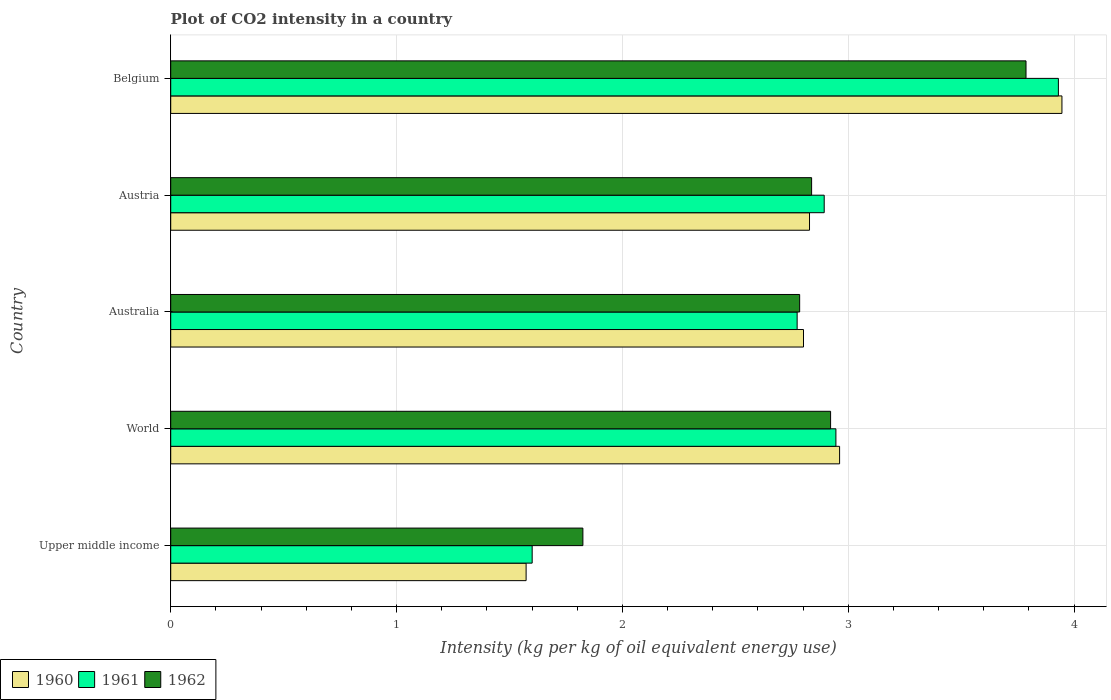Are the number of bars on each tick of the Y-axis equal?
Your answer should be compact. Yes. How many bars are there on the 2nd tick from the top?
Your answer should be very brief. 3. How many bars are there on the 5th tick from the bottom?
Your answer should be compact. 3. What is the label of the 1st group of bars from the top?
Provide a succinct answer. Belgium. In how many cases, is the number of bars for a given country not equal to the number of legend labels?
Provide a succinct answer. 0. What is the CO2 intensity in in 1962 in Upper middle income?
Make the answer very short. 1.82. Across all countries, what is the maximum CO2 intensity in in 1960?
Provide a succinct answer. 3.95. Across all countries, what is the minimum CO2 intensity in in 1962?
Your answer should be very brief. 1.82. In which country was the CO2 intensity in in 1961 maximum?
Give a very brief answer. Belgium. In which country was the CO2 intensity in in 1962 minimum?
Offer a very short reply. Upper middle income. What is the total CO2 intensity in in 1962 in the graph?
Ensure brevity in your answer.  14.16. What is the difference between the CO2 intensity in in 1960 in Upper middle income and that in World?
Your answer should be very brief. -1.39. What is the difference between the CO2 intensity in in 1961 in World and the CO2 intensity in in 1962 in Australia?
Your response must be concise. 0.16. What is the average CO2 intensity in in 1960 per country?
Your response must be concise. 2.82. What is the difference between the CO2 intensity in in 1962 and CO2 intensity in in 1961 in Belgium?
Give a very brief answer. -0.14. What is the ratio of the CO2 intensity in in 1961 in Australia to that in Upper middle income?
Your answer should be compact. 1.73. Is the CO2 intensity in in 1960 in Belgium less than that in World?
Your response must be concise. No. What is the difference between the highest and the second highest CO2 intensity in in 1961?
Your answer should be compact. 0.99. What is the difference between the highest and the lowest CO2 intensity in in 1961?
Offer a very short reply. 2.33. What does the 2nd bar from the top in World represents?
Your answer should be compact. 1961. Is it the case that in every country, the sum of the CO2 intensity in in 1962 and CO2 intensity in in 1961 is greater than the CO2 intensity in in 1960?
Your answer should be compact. Yes. Are all the bars in the graph horizontal?
Keep it short and to the point. Yes. How many countries are there in the graph?
Give a very brief answer. 5. What is the difference between two consecutive major ticks on the X-axis?
Make the answer very short. 1. Does the graph contain any zero values?
Your answer should be compact. No. What is the title of the graph?
Offer a terse response. Plot of CO2 intensity in a country. What is the label or title of the X-axis?
Your answer should be compact. Intensity (kg per kg of oil equivalent energy use). What is the Intensity (kg per kg of oil equivalent energy use) of 1960 in Upper middle income?
Your response must be concise. 1.57. What is the Intensity (kg per kg of oil equivalent energy use) in 1961 in Upper middle income?
Make the answer very short. 1.6. What is the Intensity (kg per kg of oil equivalent energy use) in 1962 in Upper middle income?
Give a very brief answer. 1.82. What is the Intensity (kg per kg of oil equivalent energy use) in 1960 in World?
Your response must be concise. 2.96. What is the Intensity (kg per kg of oil equivalent energy use) in 1961 in World?
Your answer should be compact. 2.95. What is the Intensity (kg per kg of oil equivalent energy use) of 1962 in World?
Make the answer very short. 2.92. What is the Intensity (kg per kg of oil equivalent energy use) in 1960 in Australia?
Provide a succinct answer. 2.8. What is the Intensity (kg per kg of oil equivalent energy use) of 1961 in Australia?
Provide a short and direct response. 2.77. What is the Intensity (kg per kg of oil equivalent energy use) of 1962 in Australia?
Your response must be concise. 2.78. What is the Intensity (kg per kg of oil equivalent energy use) in 1960 in Austria?
Offer a very short reply. 2.83. What is the Intensity (kg per kg of oil equivalent energy use) in 1961 in Austria?
Give a very brief answer. 2.89. What is the Intensity (kg per kg of oil equivalent energy use) of 1962 in Austria?
Ensure brevity in your answer.  2.84. What is the Intensity (kg per kg of oil equivalent energy use) of 1960 in Belgium?
Your response must be concise. 3.95. What is the Intensity (kg per kg of oil equivalent energy use) of 1961 in Belgium?
Keep it short and to the point. 3.93. What is the Intensity (kg per kg of oil equivalent energy use) in 1962 in Belgium?
Your response must be concise. 3.79. Across all countries, what is the maximum Intensity (kg per kg of oil equivalent energy use) of 1960?
Ensure brevity in your answer.  3.95. Across all countries, what is the maximum Intensity (kg per kg of oil equivalent energy use) of 1961?
Give a very brief answer. 3.93. Across all countries, what is the maximum Intensity (kg per kg of oil equivalent energy use) in 1962?
Make the answer very short. 3.79. Across all countries, what is the minimum Intensity (kg per kg of oil equivalent energy use) in 1960?
Your answer should be very brief. 1.57. Across all countries, what is the minimum Intensity (kg per kg of oil equivalent energy use) in 1961?
Provide a short and direct response. 1.6. Across all countries, what is the minimum Intensity (kg per kg of oil equivalent energy use) of 1962?
Provide a short and direct response. 1.82. What is the total Intensity (kg per kg of oil equivalent energy use) of 1960 in the graph?
Your response must be concise. 14.11. What is the total Intensity (kg per kg of oil equivalent energy use) in 1961 in the graph?
Provide a short and direct response. 14.14. What is the total Intensity (kg per kg of oil equivalent energy use) of 1962 in the graph?
Your answer should be compact. 14.16. What is the difference between the Intensity (kg per kg of oil equivalent energy use) of 1960 in Upper middle income and that in World?
Your answer should be very brief. -1.39. What is the difference between the Intensity (kg per kg of oil equivalent energy use) of 1961 in Upper middle income and that in World?
Your answer should be compact. -1.34. What is the difference between the Intensity (kg per kg of oil equivalent energy use) in 1962 in Upper middle income and that in World?
Make the answer very short. -1.1. What is the difference between the Intensity (kg per kg of oil equivalent energy use) in 1960 in Upper middle income and that in Australia?
Your response must be concise. -1.23. What is the difference between the Intensity (kg per kg of oil equivalent energy use) of 1961 in Upper middle income and that in Australia?
Offer a very short reply. -1.17. What is the difference between the Intensity (kg per kg of oil equivalent energy use) of 1962 in Upper middle income and that in Australia?
Provide a succinct answer. -0.96. What is the difference between the Intensity (kg per kg of oil equivalent energy use) of 1960 in Upper middle income and that in Austria?
Offer a very short reply. -1.25. What is the difference between the Intensity (kg per kg of oil equivalent energy use) in 1961 in Upper middle income and that in Austria?
Offer a very short reply. -1.29. What is the difference between the Intensity (kg per kg of oil equivalent energy use) of 1962 in Upper middle income and that in Austria?
Offer a terse response. -1.01. What is the difference between the Intensity (kg per kg of oil equivalent energy use) of 1960 in Upper middle income and that in Belgium?
Your answer should be compact. -2.37. What is the difference between the Intensity (kg per kg of oil equivalent energy use) of 1961 in Upper middle income and that in Belgium?
Your answer should be very brief. -2.33. What is the difference between the Intensity (kg per kg of oil equivalent energy use) of 1962 in Upper middle income and that in Belgium?
Offer a very short reply. -1.96. What is the difference between the Intensity (kg per kg of oil equivalent energy use) in 1960 in World and that in Australia?
Give a very brief answer. 0.16. What is the difference between the Intensity (kg per kg of oil equivalent energy use) of 1961 in World and that in Australia?
Ensure brevity in your answer.  0.17. What is the difference between the Intensity (kg per kg of oil equivalent energy use) in 1962 in World and that in Australia?
Your answer should be very brief. 0.14. What is the difference between the Intensity (kg per kg of oil equivalent energy use) of 1960 in World and that in Austria?
Keep it short and to the point. 0.13. What is the difference between the Intensity (kg per kg of oil equivalent energy use) in 1961 in World and that in Austria?
Keep it short and to the point. 0.05. What is the difference between the Intensity (kg per kg of oil equivalent energy use) in 1962 in World and that in Austria?
Ensure brevity in your answer.  0.08. What is the difference between the Intensity (kg per kg of oil equivalent energy use) in 1960 in World and that in Belgium?
Offer a very short reply. -0.98. What is the difference between the Intensity (kg per kg of oil equivalent energy use) in 1961 in World and that in Belgium?
Ensure brevity in your answer.  -0.99. What is the difference between the Intensity (kg per kg of oil equivalent energy use) of 1962 in World and that in Belgium?
Give a very brief answer. -0.87. What is the difference between the Intensity (kg per kg of oil equivalent energy use) in 1960 in Australia and that in Austria?
Offer a very short reply. -0.03. What is the difference between the Intensity (kg per kg of oil equivalent energy use) in 1961 in Australia and that in Austria?
Your answer should be very brief. -0.12. What is the difference between the Intensity (kg per kg of oil equivalent energy use) of 1962 in Australia and that in Austria?
Ensure brevity in your answer.  -0.05. What is the difference between the Intensity (kg per kg of oil equivalent energy use) of 1960 in Australia and that in Belgium?
Keep it short and to the point. -1.14. What is the difference between the Intensity (kg per kg of oil equivalent energy use) of 1961 in Australia and that in Belgium?
Your response must be concise. -1.16. What is the difference between the Intensity (kg per kg of oil equivalent energy use) in 1962 in Australia and that in Belgium?
Offer a terse response. -1. What is the difference between the Intensity (kg per kg of oil equivalent energy use) in 1960 in Austria and that in Belgium?
Your response must be concise. -1.12. What is the difference between the Intensity (kg per kg of oil equivalent energy use) in 1961 in Austria and that in Belgium?
Your answer should be compact. -1.04. What is the difference between the Intensity (kg per kg of oil equivalent energy use) of 1962 in Austria and that in Belgium?
Make the answer very short. -0.95. What is the difference between the Intensity (kg per kg of oil equivalent energy use) in 1960 in Upper middle income and the Intensity (kg per kg of oil equivalent energy use) in 1961 in World?
Keep it short and to the point. -1.37. What is the difference between the Intensity (kg per kg of oil equivalent energy use) in 1960 in Upper middle income and the Intensity (kg per kg of oil equivalent energy use) in 1962 in World?
Provide a short and direct response. -1.35. What is the difference between the Intensity (kg per kg of oil equivalent energy use) of 1961 in Upper middle income and the Intensity (kg per kg of oil equivalent energy use) of 1962 in World?
Ensure brevity in your answer.  -1.32. What is the difference between the Intensity (kg per kg of oil equivalent energy use) of 1960 in Upper middle income and the Intensity (kg per kg of oil equivalent energy use) of 1962 in Australia?
Ensure brevity in your answer.  -1.21. What is the difference between the Intensity (kg per kg of oil equivalent energy use) of 1961 in Upper middle income and the Intensity (kg per kg of oil equivalent energy use) of 1962 in Australia?
Ensure brevity in your answer.  -1.18. What is the difference between the Intensity (kg per kg of oil equivalent energy use) in 1960 in Upper middle income and the Intensity (kg per kg of oil equivalent energy use) in 1961 in Austria?
Keep it short and to the point. -1.32. What is the difference between the Intensity (kg per kg of oil equivalent energy use) of 1960 in Upper middle income and the Intensity (kg per kg of oil equivalent energy use) of 1962 in Austria?
Offer a terse response. -1.26. What is the difference between the Intensity (kg per kg of oil equivalent energy use) in 1961 in Upper middle income and the Intensity (kg per kg of oil equivalent energy use) in 1962 in Austria?
Your answer should be compact. -1.24. What is the difference between the Intensity (kg per kg of oil equivalent energy use) in 1960 in Upper middle income and the Intensity (kg per kg of oil equivalent energy use) in 1961 in Belgium?
Your response must be concise. -2.36. What is the difference between the Intensity (kg per kg of oil equivalent energy use) of 1960 in Upper middle income and the Intensity (kg per kg of oil equivalent energy use) of 1962 in Belgium?
Keep it short and to the point. -2.21. What is the difference between the Intensity (kg per kg of oil equivalent energy use) in 1961 in Upper middle income and the Intensity (kg per kg of oil equivalent energy use) in 1962 in Belgium?
Provide a succinct answer. -2.19. What is the difference between the Intensity (kg per kg of oil equivalent energy use) in 1960 in World and the Intensity (kg per kg of oil equivalent energy use) in 1961 in Australia?
Provide a short and direct response. 0.19. What is the difference between the Intensity (kg per kg of oil equivalent energy use) in 1960 in World and the Intensity (kg per kg of oil equivalent energy use) in 1962 in Australia?
Your response must be concise. 0.18. What is the difference between the Intensity (kg per kg of oil equivalent energy use) of 1961 in World and the Intensity (kg per kg of oil equivalent energy use) of 1962 in Australia?
Offer a terse response. 0.16. What is the difference between the Intensity (kg per kg of oil equivalent energy use) in 1960 in World and the Intensity (kg per kg of oil equivalent energy use) in 1961 in Austria?
Give a very brief answer. 0.07. What is the difference between the Intensity (kg per kg of oil equivalent energy use) in 1960 in World and the Intensity (kg per kg of oil equivalent energy use) in 1962 in Austria?
Keep it short and to the point. 0.12. What is the difference between the Intensity (kg per kg of oil equivalent energy use) in 1961 in World and the Intensity (kg per kg of oil equivalent energy use) in 1962 in Austria?
Make the answer very short. 0.11. What is the difference between the Intensity (kg per kg of oil equivalent energy use) of 1960 in World and the Intensity (kg per kg of oil equivalent energy use) of 1961 in Belgium?
Your answer should be very brief. -0.97. What is the difference between the Intensity (kg per kg of oil equivalent energy use) in 1960 in World and the Intensity (kg per kg of oil equivalent energy use) in 1962 in Belgium?
Your response must be concise. -0.83. What is the difference between the Intensity (kg per kg of oil equivalent energy use) of 1961 in World and the Intensity (kg per kg of oil equivalent energy use) of 1962 in Belgium?
Provide a succinct answer. -0.84. What is the difference between the Intensity (kg per kg of oil equivalent energy use) in 1960 in Australia and the Intensity (kg per kg of oil equivalent energy use) in 1961 in Austria?
Your response must be concise. -0.09. What is the difference between the Intensity (kg per kg of oil equivalent energy use) in 1960 in Australia and the Intensity (kg per kg of oil equivalent energy use) in 1962 in Austria?
Your answer should be compact. -0.04. What is the difference between the Intensity (kg per kg of oil equivalent energy use) in 1961 in Australia and the Intensity (kg per kg of oil equivalent energy use) in 1962 in Austria?
Your answer should be very brief. -0.06. What is the difference between the Intensity (kg per kg of oil equivalent energy use) of 1960 in Australia and the Intensity (kg per kg of oil equivalent energy use) of 1961 in Belgium?
Your answer should be very brief. -1.13. What is the difference between the Intensity (kg per kg of oil equivalent energy use) of 1960 in Australia and the Intensity (kg per kg of oil equivalent energy use) of 1962 in Belgium?
Your answer should be compact. -0.99. What is the difference between the Intensity (kg per kg of oil equivalent energy use) of 1961 in Australia and the Intensity (kg per kg of oil equivalent energy use) of 1962 in Belgium?
Provide a short and direct response. -1.01. What is the difference between the Intensity (kg per kg of oil equivalent energy use) in 1960 in Austria and the Intensity (kg per kg of oil equivalent energy use) in 1961 in Belgium?
Make the answer very short. -1.1. What is the difference between the Intensity (kg per kg of oil equivalent energy use) in 1960 in Austria and the Intensity (kg per kg of oil equivalent energy use) in 1962 in Belgium?
Make the answer very short. -0.96. What is the difference between the Intensity (kg per kg of oil equivalent energy use) of 1961 in Austria and the Intensity (kg per kg of oil equivalent energy use) of 1962 in Belgium?
Offer a very short reply. -0.89. What is the average Intensity (kg per kg of oil equivalent energy use) of 1960 per country?
Keep it short and to the point. 2.82. What is the average Intensity (kg per kg of oil equivalent energy use) in 1961 per country?
Make the answer very short. 2.83. What is the average Intensity (kg per kg of oil equivalent energy use) in 1962 per country?
Your response must be concise. 2.83. What is the difference between the Intensity (kg per kg of oil equivalent energy use) of 1960 and Intensity (kg per kg of oil equivalent energy use) of 1961 in Upper middle income?
Give a very brief answer. -0.03. What is the difference between the Intensity (kg per kg of oil equivalent energy use) of 1960 and Intensity (kg per kg of oil equivalent energy use) of 1962 in Upper middle income?
Your response must be concise. -0.25. What is the difference between the Intensity (kg per kg of oil equivalent energy use) in 1961 and Intensity (kg per kg of oil equivalent energy use) in 1962 in Upper middle income?
Keep it short and to the point. -0.22. What is the difference between the Intensity (kg per kg of oil equivalent energy use) in 1960 and Intensity (kg per kg of oil equivalent energy use) in 1961 in World?
Make the answer very short. 0.02. What is the difference between the Intensity (kg per kg of oil equivalent energy use) of 1960 and Intensity (kg per kg of oil equivalent energy use) of 1962 in World?
Your answer should be very brief. 0.04. What is the difference between the Intensity (kg per kg of oil equivalent energy use) of 1961 and Intensity (kg per kg of oil equivalent energy use) of 1962 in World?
Give a very brief answer. 0.02. What is the difference between the Intensity (kg per kg of oil equivalent energy use) in 1960 and Intensity (kg per kg of oil equivalent energy use) in 1961 in Australia?
Offer a very short reply. 0.03. What is the difference between the Intensity (kg per kg of oil equivalent energy use) in 1960 and Intensity (kg per kg of oil equivalent energy use) in 1962 in Australia?
Make the answer very short. 0.02. What is the difference between the Intensity (kg per kg of oil equivalent energy use) of 1961 and Intensity (kg per kg of oil equivalent energy use) of 1962 in Australia?
Keep it short and to the point. -0.01. What is the difference between the Intensity (kg per kg of oil equivalent energy use) of 1960 and Intensity (kg per kg of oil equivalent energy use) of 1961 in Austria?
Your answer should be very brief. -0.07. What is the difference between the Intensity (kg per kg of oil equivalent energy use) in 1960 and Intensity (kg per kg of oil equivalent energy use) in 1962 in Austria?
Offer a terse response. -0.01. What is the difference between the Intensity (kg per kg of oil equivalent energy use) of 1961 and Intensity (kg per kg of oil equivalent energy use) of 1962 in Austria?
Your response must be concise. 0.06. What is the difference between the Intensity (kg per kg of oil equivalent energy use) in 1960 and Intensity (kg per kg of oil equivalent energy use) in 1961 in Belgium?
Your response must be concise. 0.02. What is the difference between the Intensity (kg per kg of oil equivalent energy use) in 1960 and Intensity (kg per kg of oil equivalent energy use) in 1962 in Belgium?
Make the answer very short. 0.16. What is the difference between the Intensity (kg per kg of oil equivalent energy use) in 1961 and Intensity (kg per kg of oil equivalent energy use) in 1962 in Belgium?
Offer a terse response. 0.14. What is the ratio of the Intensity (kg per kg of oil equivalent energy use) in 1960 in Upper middle income to that in World?
Provide a short and direct response. 0.53. What is the ratio of the Intensity (kg per kg of oil equivalent energy use) of 1961 in Upper middle income to that in World?
Ensure brevity in your answer.  0.54. What is the ratio of the Intensity (kg per kg of oil equivalent energy use) in 1962 in Upper middle income to that in World?
Provide a succinct answer. 0.62. What is the ratio of the Intensity (kg per kg of oil equivalent energy use) in 1960 in Upper middle income to that in Australia?
Give a very brief answer. 0.56. What is the ratio of the Intensity (kg per kg of oil equivalent energy use) in 1961 in Upper middle income to that in Australia?
Give a very brief answer. 0.58. What is the ratio of the Intensity (kg per kg of oil equivalent energy use) in 1962 in Upper middle income to that in Australia?
Offer a very short reply. 0.66. What is the ratio of the Intensity (kg per kg of oil equivalent energy use) of 1960 in Upper middle income to that in Austria?
Provide a succinct answer. 0.56. What is the ratio of the Intensity (kg per kg of oil equivalent energy use) in 1961 in Upper middle income to that in Austria?
Provide a short and direct response. 0.55. What is the ratio of the Intensity (kg per kg of oil equivalent energy use) in 1962 in Upper middle income to that in Austria?
Give a very brief answer. 0.64. What is the ratio of the Intensity (kg per kg of oil equivalent energy use) of 1960 in Upper middle income to that in Belgium?
Provide a short and direct response. 0.4. What is the ratio of the Intensity (kg per kg of oil equivalent energy use) in 1961 in Upper middle income to that in Belgium?
Keep it short and to the point. 0.41. What is the ratio of the Intensity (kg per kg of oil equivalent energy use) of 1962 in Upper middle income to that in Belgium?
Your answer should be very brief. 0.48. What is the ratio of the Intensity (kg per kg of oil equivalent energy use) of 1960 in World to that in Australia?
Keep it short and to the point. 1.06. What is the ratio of the Intensity (kg per kg of oil equivalent energy use) in 1961 in World to that in Australia?
Make the answer very short. 1.06. What is the ratio of the Intensity (kg per kg of oil equivalent energy use) of 1962 in World to that in Australia?
Make the answer very short. 1.05. What is the ratio of the Intensity (kg per kg of oil equivalent energy use) in 1960 in World to that in Austria?
Your answer should be very brief. 1.05. What is the ratio of the Intensity (kg per kg of oil equivalent energy use) in 1961 in World to that in Austria?
Ensure brevity in your answer.  1.02. What is the ratio of the Intensity (kg per kg of oil equivalent energy use) of 1962 in World to that in Austria?
Your response must be concise. 1.03. What is the ratio of the Intensity (kg per kg of oil equivalent energy use) of 1960 in World to that in Belgium?
Your answer should be compact. 0.75. What is the ratio of the Intensity (kg per kg of oil equivalent energy use) of 1961 in World to that in Belgium?
Your response must be concise. 0.75. What is the ratio of the Intensity (kg per kg of oil equivalent energy use) in 1962 in World to that in Belgium?
Offer a terse response. 0.77. What is the ratio of the Intensity (kg per kg of oil equivalent energy use) of 1960 in Australia to that in Austria?
Keep it short and to the point. 0.99. What is the ratio of the Intensity (kg per kg of oil equivalent energy use) in 1961 in Australia to that in Austria?
Provide a short and direct response. 0.96. What is the ratio of the Intensity (kg per kg of oil equivalent energy use) in 1962 in Australia to that in Austria?
Your answer should be compact. 0.98. What is the ratio of the Intensity (kg per kg of oil equivalent energy use) of 1960 in Australia to that in Belgium?
Ensure brevity in your answer.  0.71. What is the ratio of the Intensity (kg per kg of oil equivalent energy use) in 1961 in Australia to that in Belgium?
Provide a succinct answer. 0.71. What is the ratio of the Intensity (kg per kg of oil equivalent energy use) of 1962 in Australia to that in Belgium?
Your answer should be compact. 0.74. What is the ratio of the Intensity (kg per kg of oil equivalent energy use) of 1960 in Austria to that in Belgium?
Give a very brief answer. 0.72. What is the ratio of the Intensity (kg per kg of oil equivalent energy use) in 1961 in Austria to that in Belgium?
Your answer should be compact. 0.74. What is the ratio of the Intensity (kg per kg of oil equivalent energy use) of 1962 in Austria to that in Belgium?
Keep it short and to the point. 0.75. What is the difference between the highest and the second highest Intensity (kg per kg of oil equivalent energy use) of 1960?
Make the answer very short. 0.98. What is the difference between the highest and the second highest Intensity (kg per kg of oil equivalent energy use) in 1961?
Provide a short and direct response. 0.99. What is the difference between the highest and the second highest Intensity (kg per kg of oil equivalent energy use) in 1962?
Provide a succinct answer. 0.87. What is the difference between the highest and the lowest Intensity (kg per kg of oil equivalent energy use) in 1960?
Your response must be concise. 2.37. What is the difference between the highest and the lowest Intensity (kg per kg of oil equivalent energy use) of 1961?
Your answer should be very brief. 2.33. What is the difference between the highest and the lowest Intensity (kg per kg of oil equivalent energy use) in 1962?
Offer a very short reply. 1.96. 